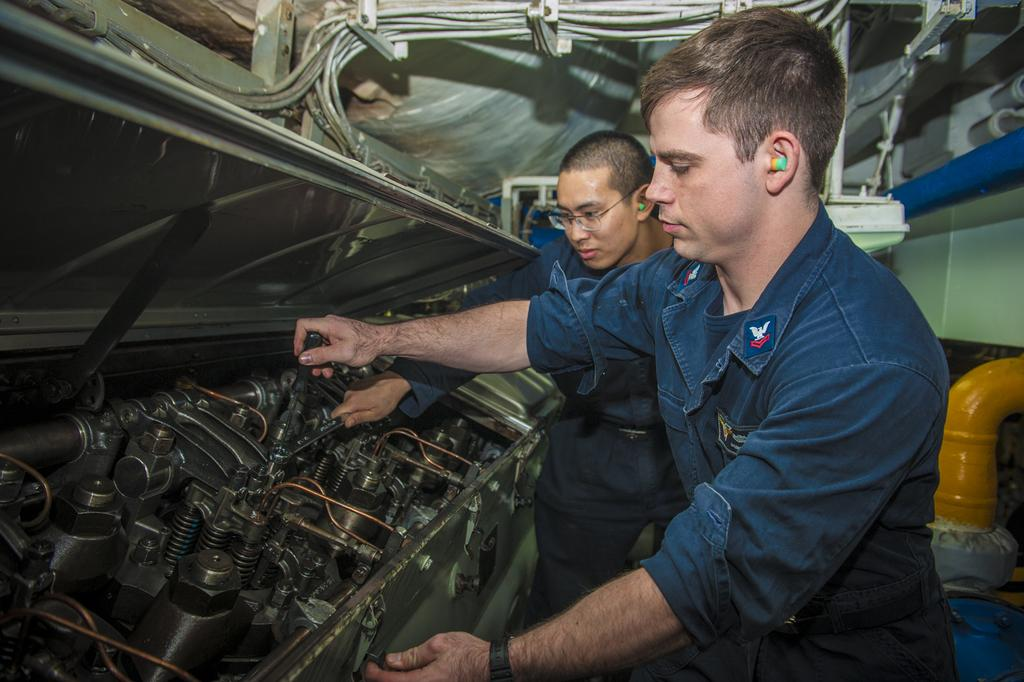How many people are in the image? There are two persons in the image. What are the persons holding in the image? The persons are holding tools. What protective gear are the persons wearing? The persons are wearing ear plugs. Can you describe one person's appearance? One person is wearing glasses (specs). What type of equipment can be seen in the image? There is a machine with bolts and copper wires in the image. What other objects are present in the image? There are pipes in the image. What type of flock is visible in the image? There is no flock present in the image; it features two people holding tools and working with equipment. What kind of lunch is being prepared in the image? There is no indication of food or lunch preparation in the image. 